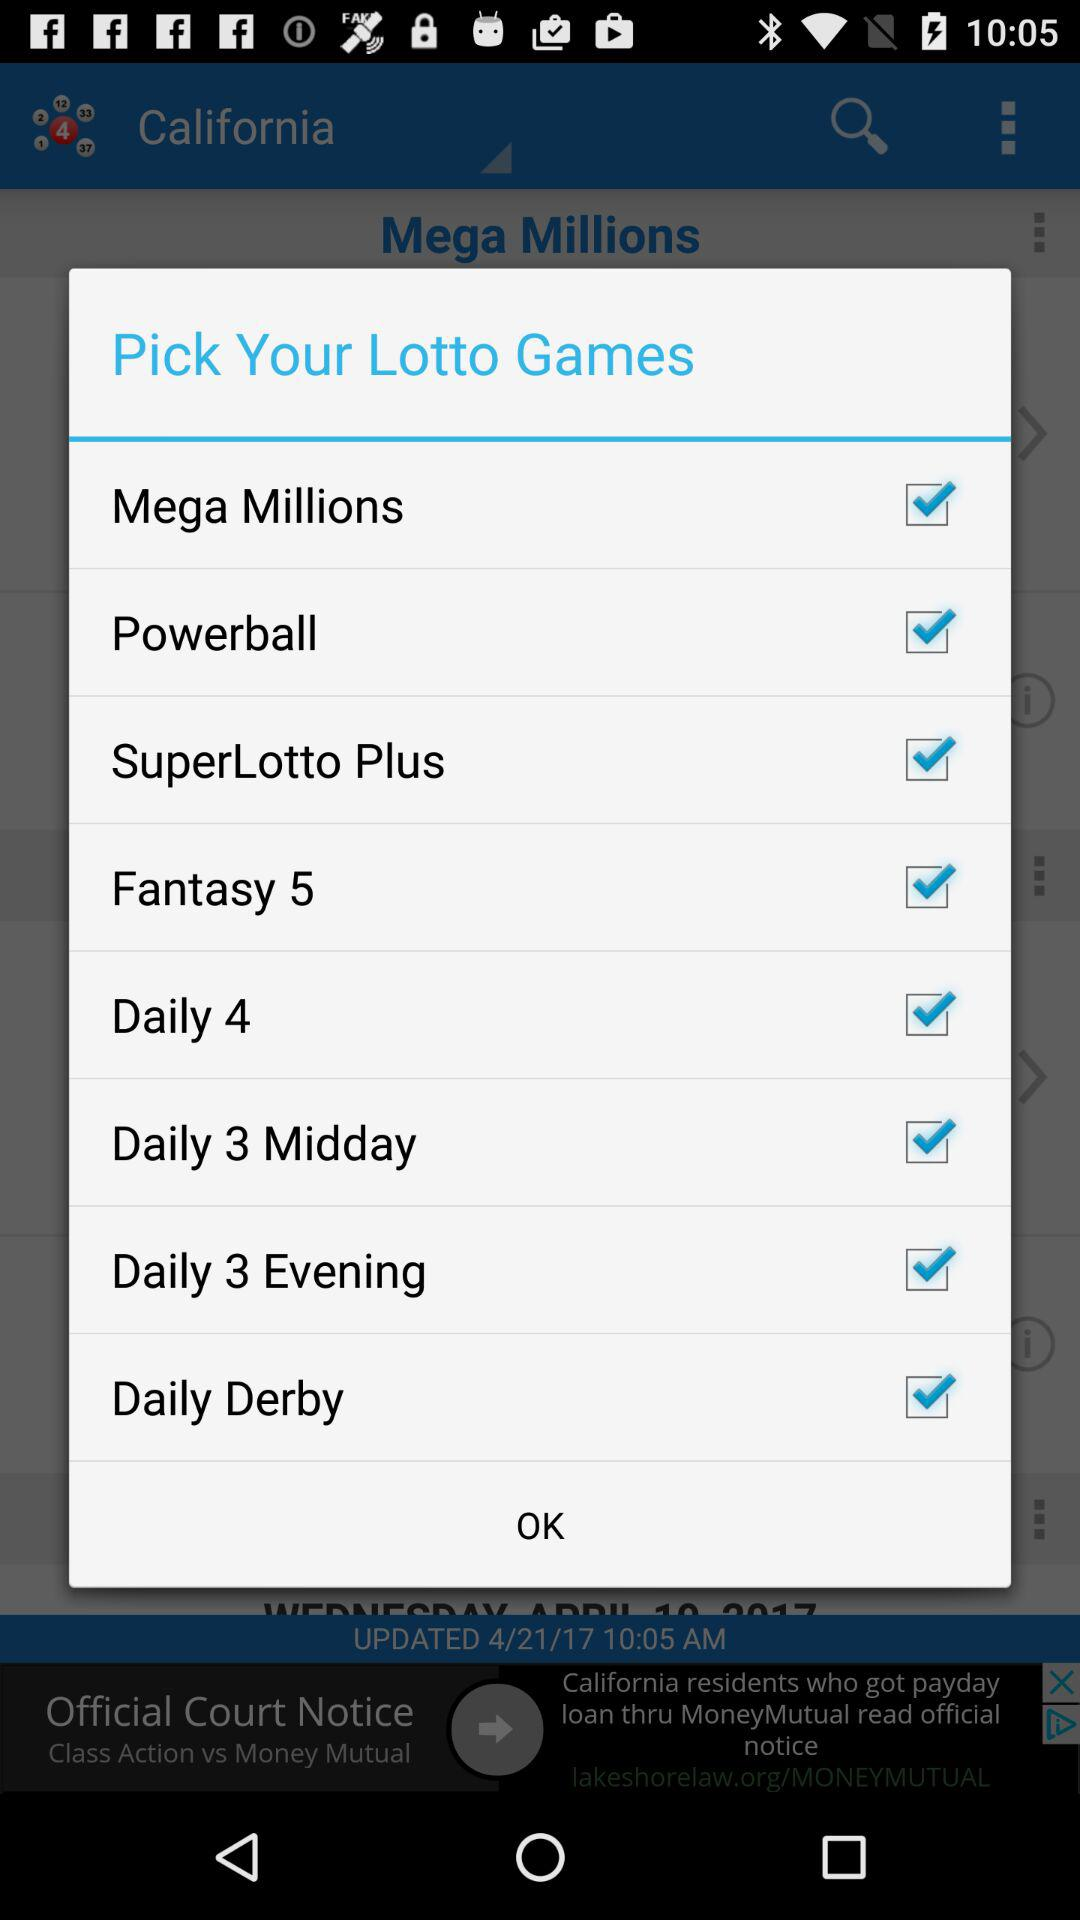How many lottery games are available?
Answer the question using a single word or phrase. 8 